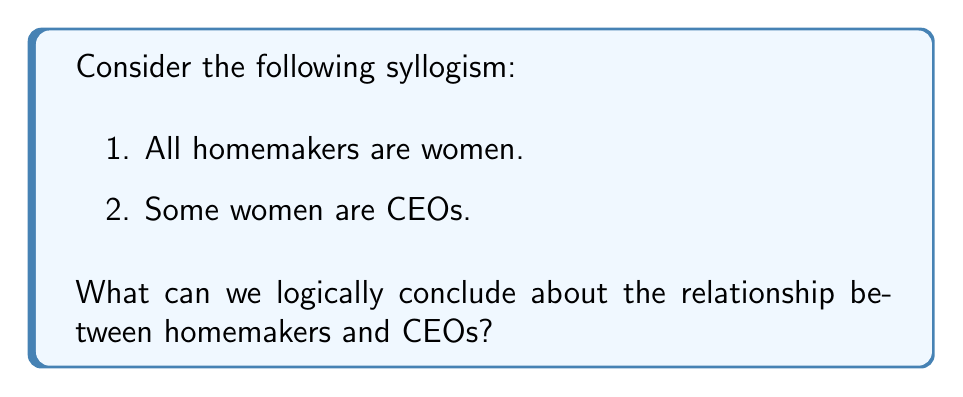Teach me how to tackle this problem. Let's approach this syllogism step-by-step using set theory and Venn diagrams:

1. First, let's define our sets:
   H: Homemakers
   W: Women
   C: CEOs

2. The premises can be translated as:
   Premise 1: $H \subseteq W$ (All homemakers are women)
   Premise 2: $W \cap C \neq \emptyset$ (Some women are CEOs)

3. Let's visualize this with a Venn diagram:

[asy]
unitsize(1cm);

pair A = (0,0), B = (1.5,0), C = (0.75,1.3);
real r = 1;

draw(circle(A,r), blue);
draw(circle(B,r), red);
draw(circle(C,r), green);

label("W", A, SW);
label("C", B, SE);
label("H", C, N);

fill(intersectionpoint(circle(A,r), circle(C,r))--arc(C,r,180,360)--cycle, blue+opacity(0.2));
fill(intersectionpoint(circle(A,r), circle(B,r))--arc(A,r,0,60)--arc(B,r,120,180)--cycle, purple+opacity(0.2));

[/asy]

4. From the diagram, we can see that:
   - The set H (Homemakers) is entirely within W (Women)
   - There is an intersection between W (Women) and C (CEOs)

5. However, we cannot determine from this information whether there is any overlap between H (Homemakers) and C (CEOs). The intersection could exist, but it's not guaranteed by the given premises.

6. Therefore, we cannot make any definitive conclusion about the relationship between homemakers and CEOs based on these premises alone.
Answer: No valid conclusion can be drawn about the relationship between homemakers and CEOs from the given premises. 